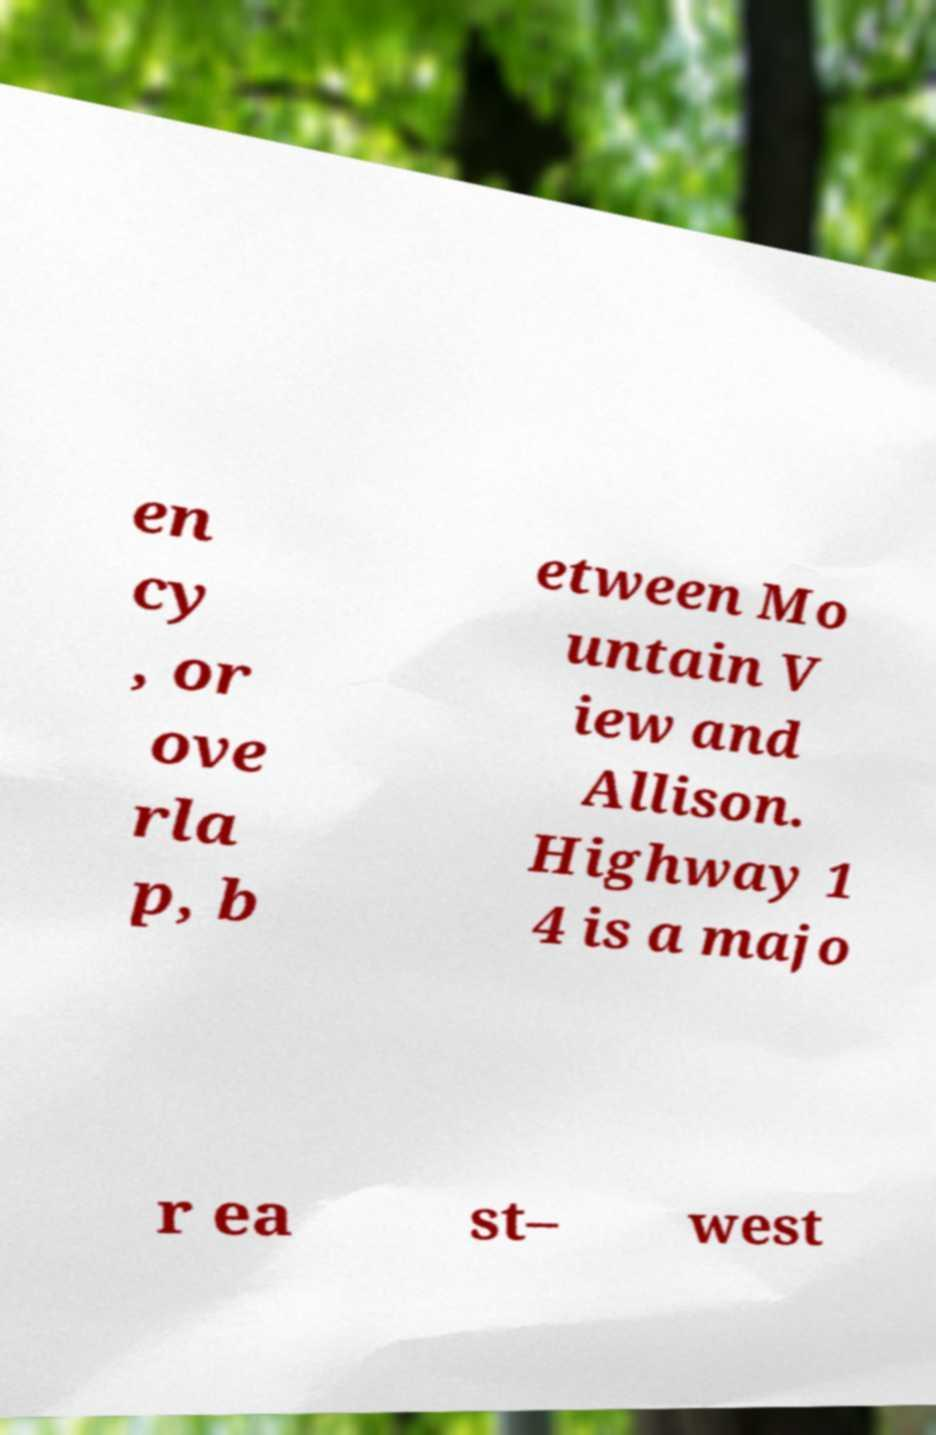Can you read and provide the text displayed in the image?This photo seems to have some interesting text. Can you extract and type it out for me? en cy , or ove rla p, b etween Mo untain V iew and Allison. Highway 1 4 is a majo r ea st– west 